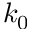<formula> <loc_0><loc_0><loc_500><loc_500>k _ { 0 }</formula> 